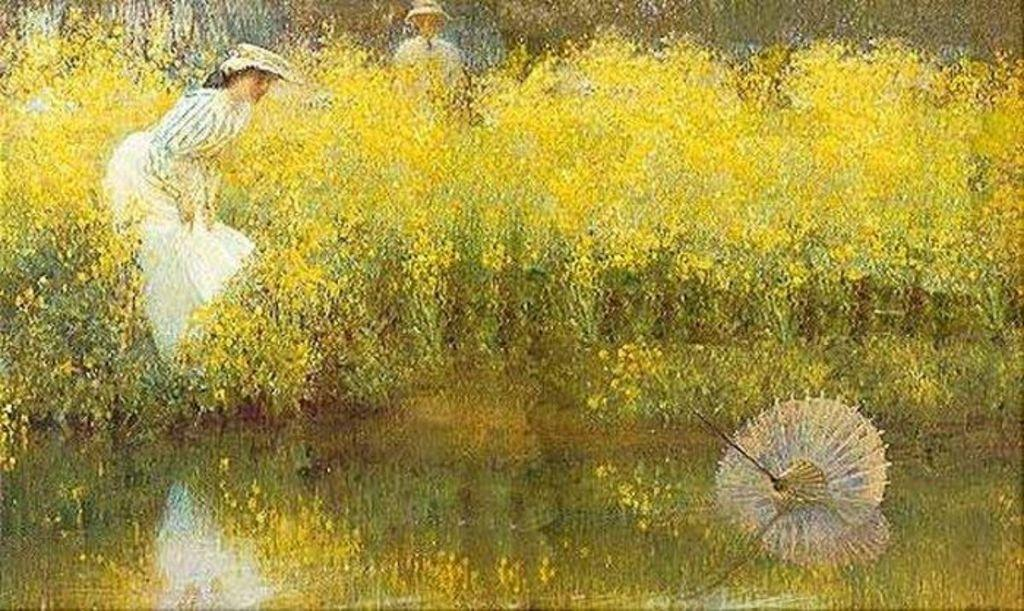What is the main subject of the image? The image contains a painting. What is depicted in the painting? The painting depicts people and plants. Are there any specific elements within the plants? Yes, the painting features flowers. What other object can be seen in the painting? The painting has an umbrella in the water. What type of juice is being served in the painting? There is no juice present in the painting; it features people, plants, flowers, and an umbrella in the water. Who created the painting? The identity of the painting's creator is not mentioned in the provided facts. 